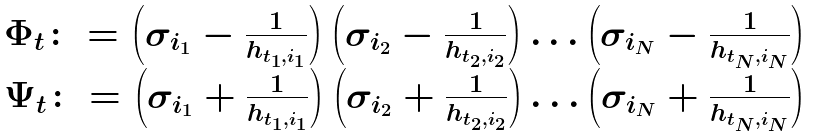Convert formula to latex. <formula><loc_0><loc_0><loc_500><loc_500>\begin{array} { c } \Phi _ { t } \colon = \left ( \sigma _ { i _ { 1 } } - \frac { 1 } { h _ { t _ { 1 } , i _ { 1 } } } \right ) \left ( \sigma _ { i _ { 2 } } - \frac { 1 } { h _ { t _ { 2 } , i _ { 2 } } } \right ) \dots \left ( \sigma _ { i _ { N } } - \frac { 1 } { h _ { t _ { N } , i _ { N } } } \right ) \\ \Psi _ { t } \colon = \left ( \sigma _ { i _ { 1 } } + \frac { 1 } { h _ { t _ { 1 } , i _ { 1 } } } \right ) \left ( \sigma _ { i _ { 2 } } + \frac { 1 } { h _ { t _ { 2 } , i _ { 2 } } } \right ) \dots \left ( \sigma _ { i _ { N } } + \frac { 1 } { h _ { t _ { N } , i _ { N } } } \right ) \end{array}</formula> 